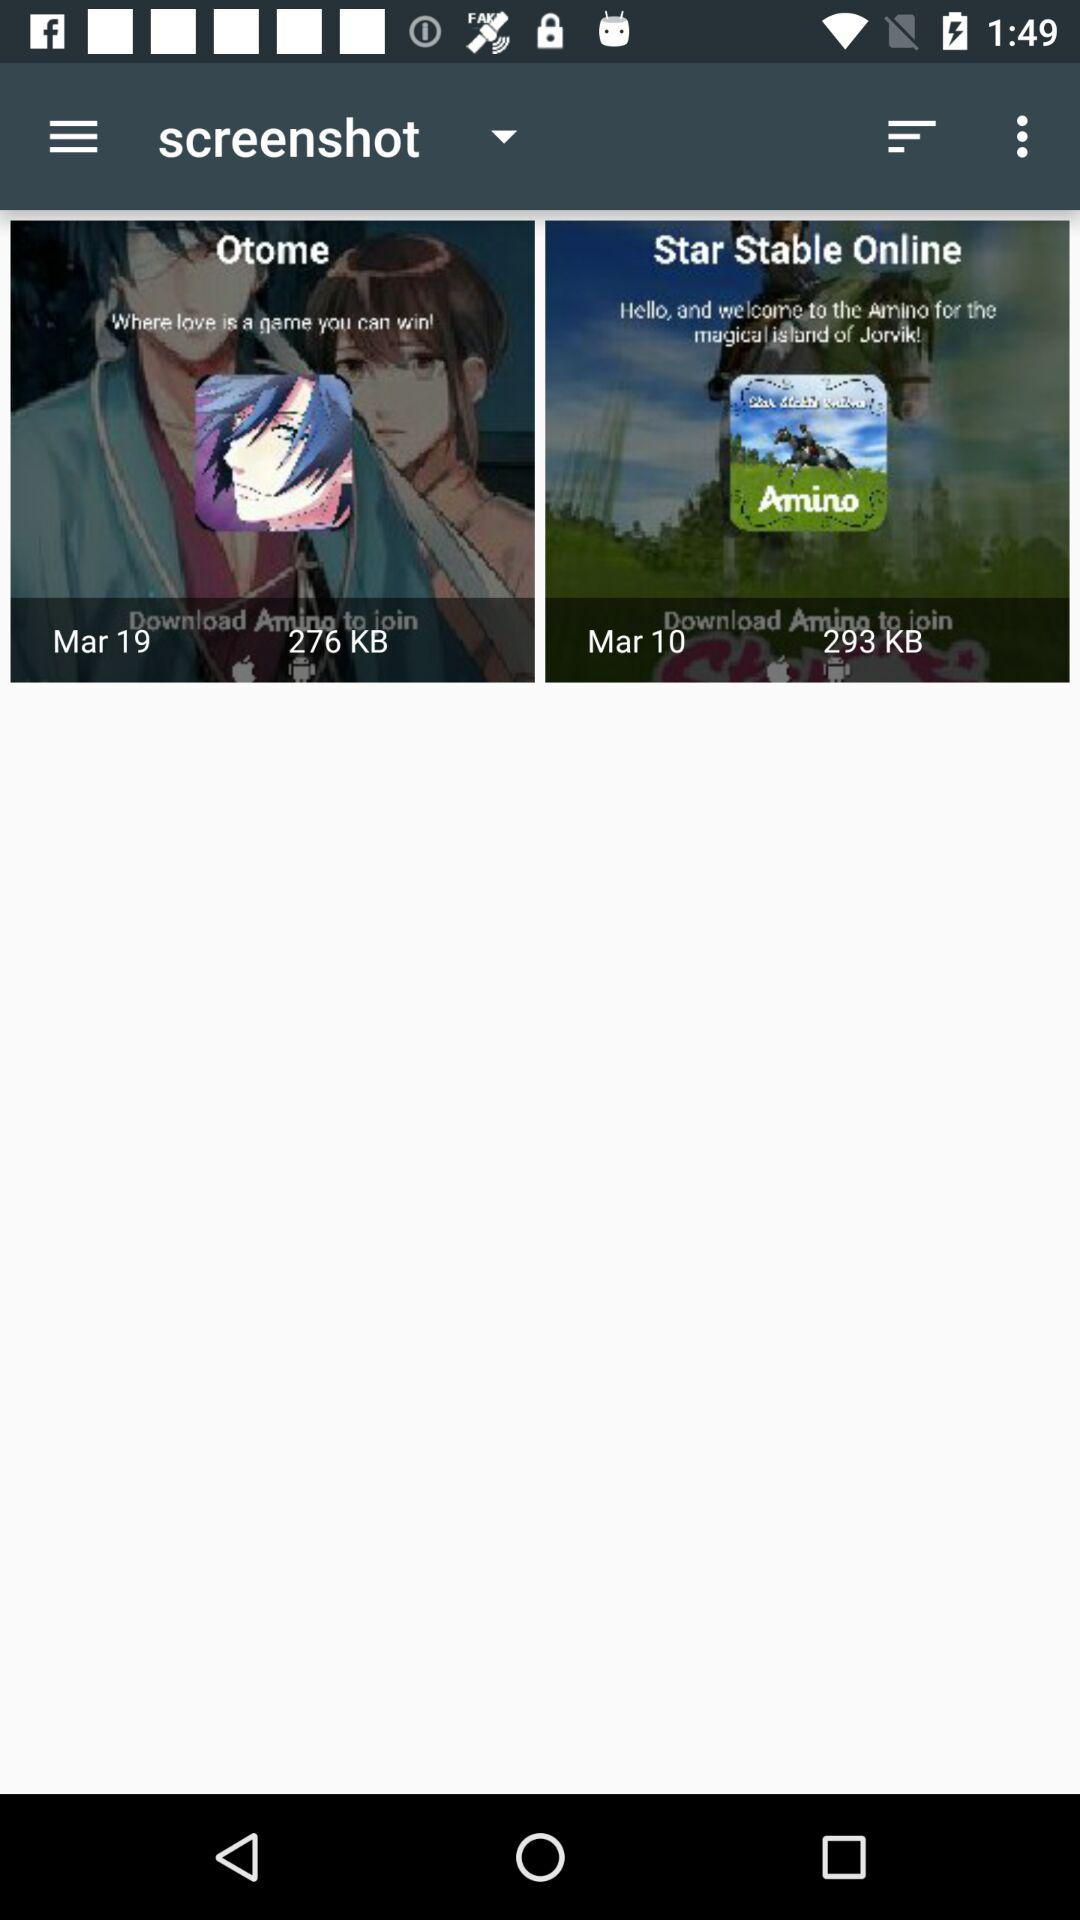What date was selected?
When the provided information is insufficient, respond with <no answer>. <no answer> 